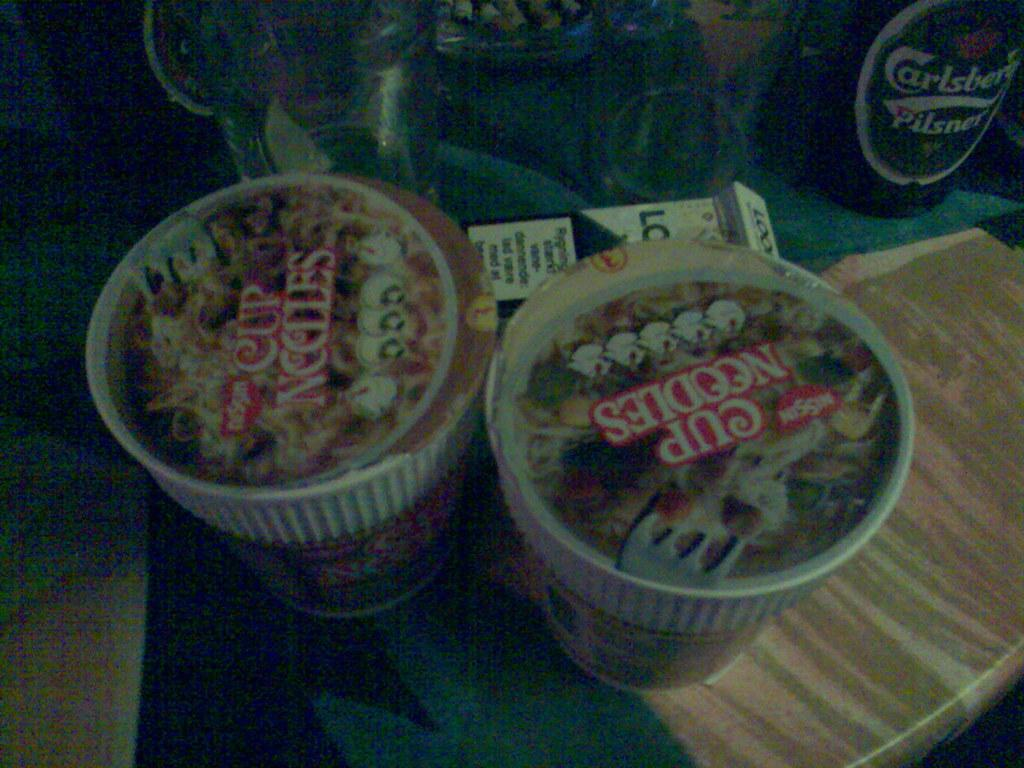What type of items can be seen in the image? There are food items, a bottle, glass objects, and a box in the image. Can you describe the bottle in the image? The bottle is one of the items visible in the image. What are the glass objects in the image used for? The glass objects in the image are likely used for serving or storing food or drinks. What is the box in the image used for? The box in the image might be used for storing or organizing items. On what object are the other objects placed? The objects are placed on another object, but the specific object is not mentioned in the provided facts. What type of pan is used to create the feeling of warmth in the image? There is no pan or feeling of warmth present in the image; it only contains food items, a bottle, glass objects, and a box. 